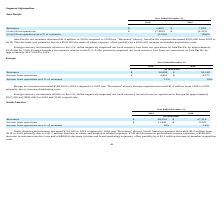From Travelzoo's financial document, What is the amount of revenues in 2019 and 2018 respectively? The document shows two values: $6,490 and $7,859 (in thousands). From the document: "Revenues $ 6,490 $ 7,859 Revenues $ 6,490 $ 7,859..." Also, What is the loss from operations in 2019 and 2018 respectively? The document shows two values: 7,488 and 6,322 (in thousands). From the document: "(Loss) from operations $ (7,488) $ (6,322) (Loss) from operations $ (7,488) $ (6,322)..." Also, How much did Asia Pacific expenses decrease by from 2018 to 2019? According to the financial document, $203,000. The relevant text states: "“Revenues” above). Asia Pacific expenses decreased $203,000 from 2018 to..." Additionally, Which year has a higher amount of revenue? According to the financial document, 2018. The relevant text states: "2019 2018..." Also, can you calculate: What is the average amount of revenues in 2018 and 2019? To answer this question, I need to perform calculations using the financial data. The calculation is: (6,490+ 7,859)/2, which equals 7174.5 (in thousands). This is based on the information: "Revenues $ 6,490 $ 7,859 Revenues $ 6,490 $ 7,859..." The key data points involved are: 6,490, 7,859. Also, can you calculate: What is the percentage change in revenue from 2018 to 2019? To answer this question, I need to perform calculations using the financial data. The calculation is: (6,490-7,859)/7,859, which equals -17.42 (percentage). This is based on the information: "Revenues $ 6,490 $ 7,859 Revenues $ 6,490 $ 7,859..." The key data points involved are: 6,490, 7,859. 